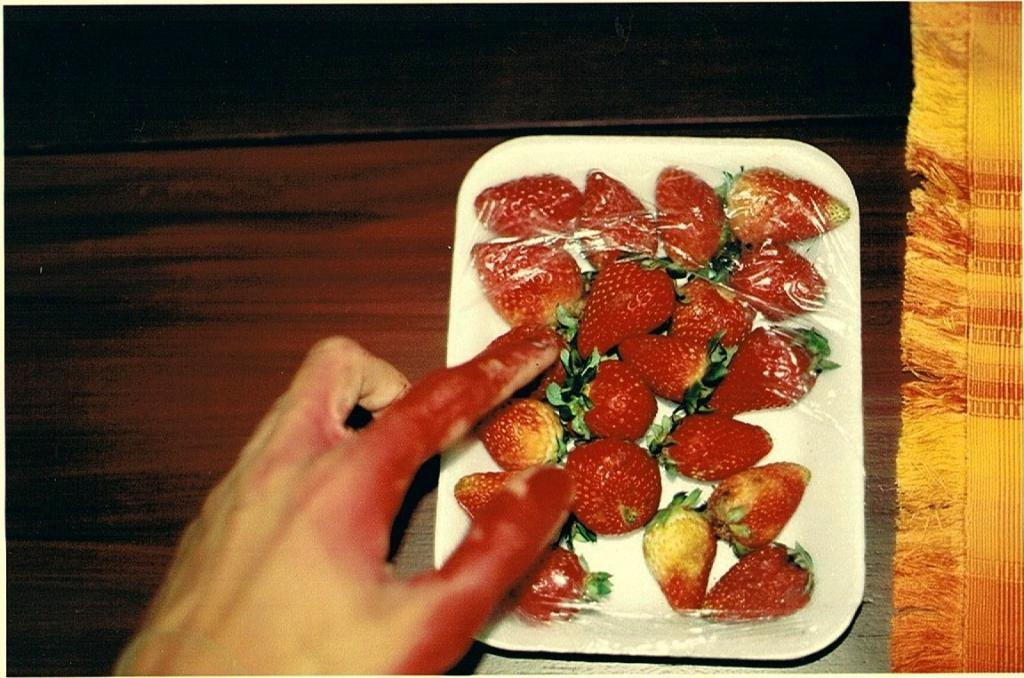What object is present in the image that can hold items? There is a tray in the image that can hold items. What is on the tray in the image? The tray contains strawberries. Whose hand is visible in the image? There is a person's hand visible in the image. How does the person's hand affect the digestion of the strawberries in the image? The person's hand does not affect the digestion of the strawberries in the image, as it is not interacting with them. 